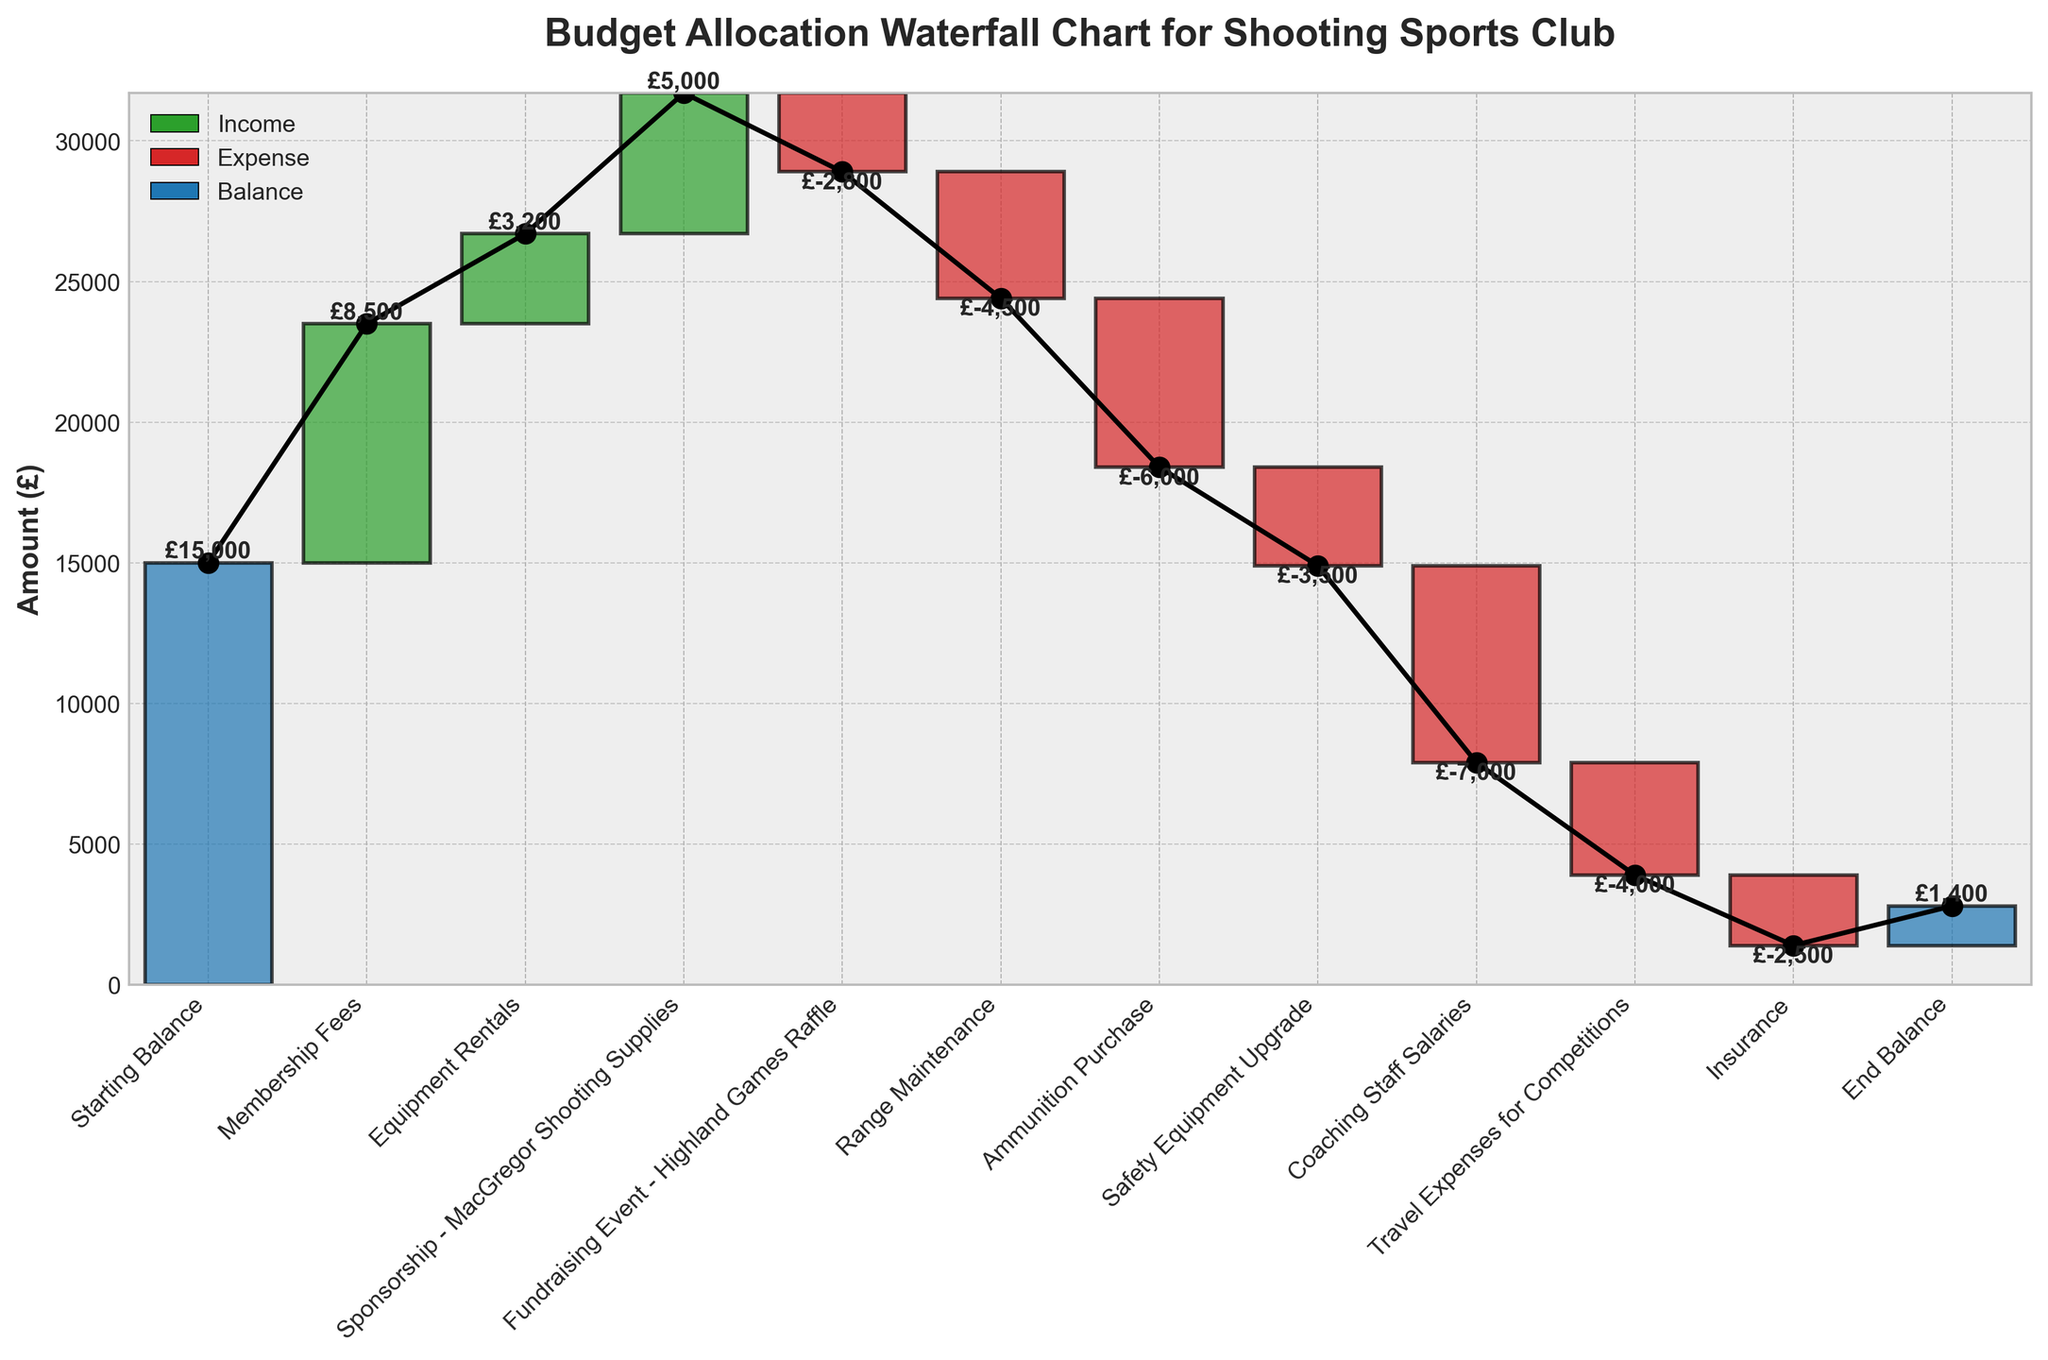what is the title of the figure? The title is usually placed at the top of the figure and is used to describe the purpose or subject of the plot. The title here is "Budget Allocation Waterfall Chart for Shooting Sports Club".
Answer: Budget Allocation Waterfall Chart for Shooting Sports Club Which category contributes the most income? In the plot, positive values in green indicate income sources. The highest green bar represents the most significant income category. "Membership Fees" appears to be the highest contributor at £8500.
Answer: Membership Fees What is the total amount spent on expenses? To find the total expenditure, sum up all negative values (red bars). Categories with expenses are: £-2800, £-4500, £-6000, £-3500, £-7000, £-4000, £-2500. Sum them: -2800 + -4500 + -6000 + -3500 + -7000 + -4000 + -2500 = -30300.
Answer: £-30,300 How does the funding from "Sponsorship - MacGregor Shooting Supplies" compare to "Fundraising Event - Highland Games Raffle"? Identify the value of both categories in the figure. "Sponsorship - MacGregor Shooting Supplies" has an amount of £5000, and "Fundraising Event - Highland Games Raffle" has an amount of £-2800. £5000 (income) is greater than £-2800 (expenditure).
Answer: Greater than What is the final budget balance? The final balance or end balance is found at the end of the cumulative bar chart. The "End Balance" category shows the amount as per the chart.
Answer: £1400 Which expense category has the highest cost? To identify the category with the highest cost, look for the largest red bar. "Coaching Staff Salaries" has the highest expense at £-7000.
Answer: Coaching Staff Salaries What is the net increase or decrease from the starting to the ending balance? Calculate the difference between the Starting Balance and End Balance. The Starting Balance is £15000, and the End Balance is £1400. The net decrease is £1400 - £15000 = £-13600.
Answer: £-13,600 How much was spent on Travel Expenses for Competitions? Look for the value associated with "Travel Expenses for Competitions" category in the plot, represented by a red bar.
Answer: £-4000 